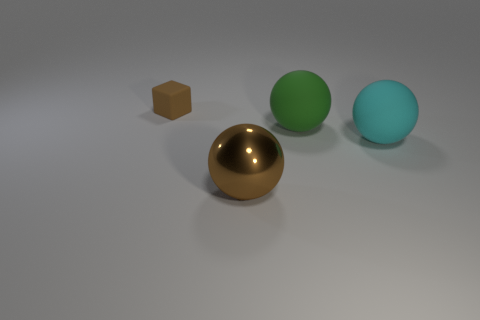Subtract 1 balls. How many balls are left? 2 Add 4 large green rubber blocks. How many objects exist? 8 Subtract all rubber balls. How many balls are left? 1 Subtract all balls. How many objects are left? 1 Subtract all brown metallic balls. Subtract all big cyan rubber objects. How many objects are left? 2 Add 1 cyan matte balls. How many cyan matte balls are left? 2 Add 3 small things. How many small things exist? 4 Subtract 0 brown cylinders. How many objects are left? 4 